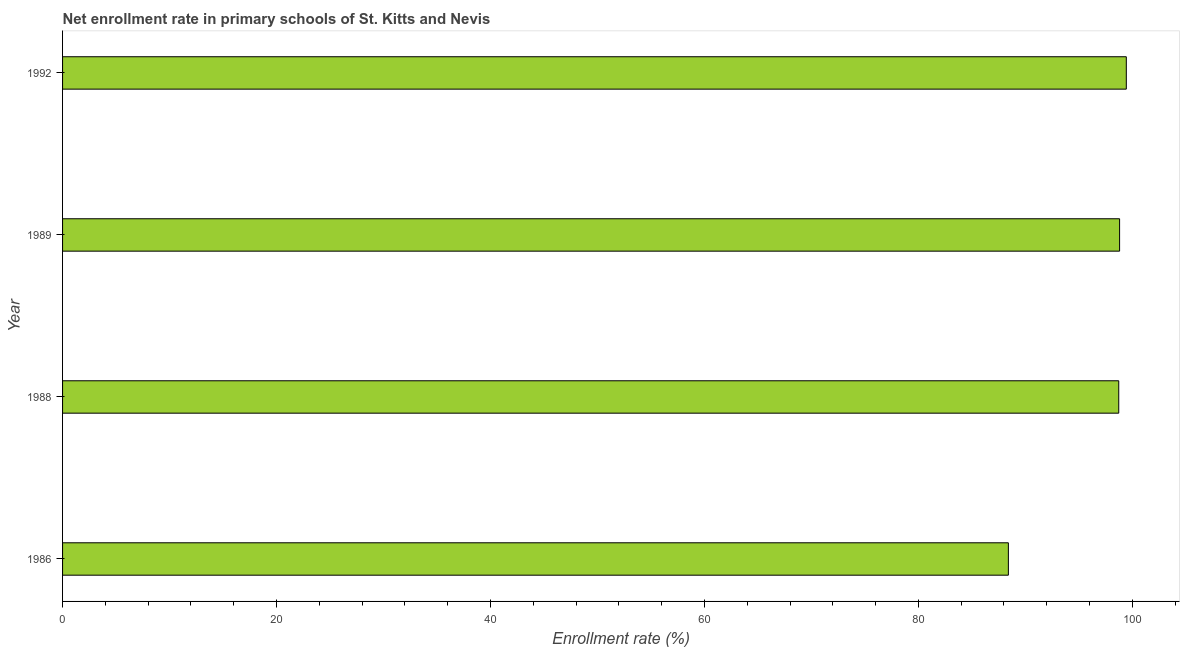Does the graph contain any zero values?
Make the answer very short. No. Does the graph contain grids?
Your answer should be compact. No. What is the title of the graph?
Provide a short and direct response. Net enrollment rate in primary schools of St. Kitts and Nevis. What is the label or title of the X-axis?
Your answer should be very brief. Enrollment rate (%). What is the label or title of the Y-axis?
Your answer should be very brief. Year. What is the net enrollment rate in primary schools in 1989?
Ensure brevity in your answer.  98.81. Across all years, what is the maximum net enrollment rate in primary schools?
Your answer should be very brief. 99.43. Across all years, what is the minimum net enrollment rate in primary schools?
Ensure brevity in your answer.  88.41. In which year was the net enrollment rate in primary schools minimum?
Your answer should be compact. 1986. What is the sum of the net enrollment rate in primary schools?
Ensure brevity in your answer.  385.38. What is the difference between the net enrollment rate in primary schools in 1986 and 1992?
Your response must be concise. -11.02. What is the average net enrollment rate in primary schools per year?
Ensure brevity in your answer.  96.34. What is the median net enrollment rate in primary schools?
Provide a short and direct response. 98.77. What is the ratio of the net enrollment rate in primary schools in 1986 to that in 1992?
Your answer should be compact. 0.89. What is the difference between the highest and the second highest net enrollment rate in primary schools?
Keep it short and to the point. 0.63. What is the difference between the highest and the lowest net enrollment rate in primary schools?
Offer a very short reply. 11.02. In how many years, is the net enrollment rate in primary schools greater than the average net enrollment rate in primary schools taken over all years?
Keep it short and to the point. 3. How many bars are there?
Provide a short and direct response. 4. How many years are there in the graph?
Offer a very short reply. 4. What is the difference between two consecutive major ticks on the X-axis?
Make the answer very short. 20. What is the Enrollment rate (%) in 1986?
Ensure brevity in your answer.  88.41. What is the Enrollment rate (%) in 1988?
Provide a short and direct response. 98.73. What is the Enrollment rate (%) in 1989?
Ensure brevity in your answer.  98.81. What is the Enrollment rate (%) in 1992?
Your answer should be very brief. 99.43. What is the difference between the Enrollment rate (%) in 1986 and 1988?
Offer a terse response. -10.32. What is the difference between the Enrollment rate (%) in 1986 and 1989?
Provide a short and direct response. -10.4. What is the difference between the Enrollment rate (%) in 1986 and 1992?
Ensure brevity in your answer.  -11.02. What is the difference between the Enrollment rate (%) in 1988 and 1989?
Offer a terse response. -0.08. What is the difference between the Enrollment rate (%) in 1988 and 1992?
Give a very brief answer. -0.71. What is the difference between the Enrollment rate (%) in 1989 and 1992?
Make the answer very short. -0.63. What is the ratio of the Enrollment rate (%) in 1986 to that in 1988?
Keep it short and to the point. 0.9. What is the ratio of the Enrollment rate (%) in 1986 to that in 1989?
Your answer should be compact. 0.9. What is the ratio of the Enrollment rate (%) in 1986 to that in 1992?
Offer a very short reply. 0.89. What is the ratio of the Enrollment rate (%) in 1988 to that in 1992?
Keep it short and to the point. 0.99. 